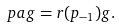Convert formula to latex. <formula><loc_0><loc_0><loc_500><loc_500>\ p a g = r ( p _ { - 1 } ) g .</formula> 